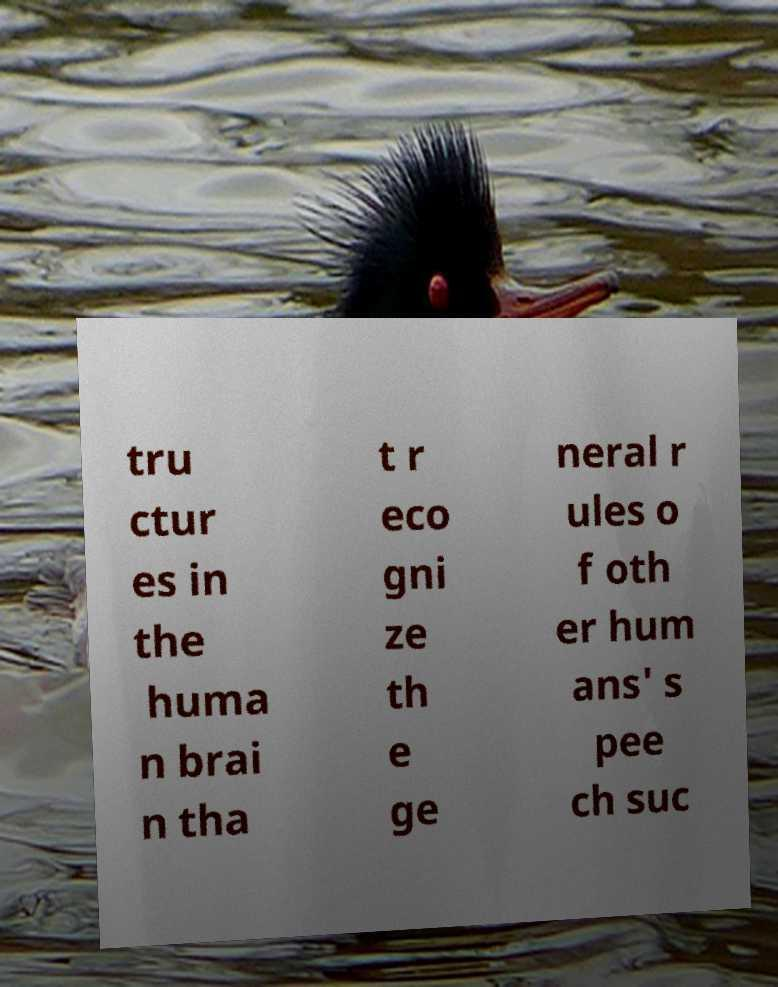There's text embedded in this image that I need extracted. Can you transcribe it verbatim? tru ctur es in the huma n brai n tha t r eco gni ze th e ge neral r ules o f oth er hum ans' s pee ch suc 